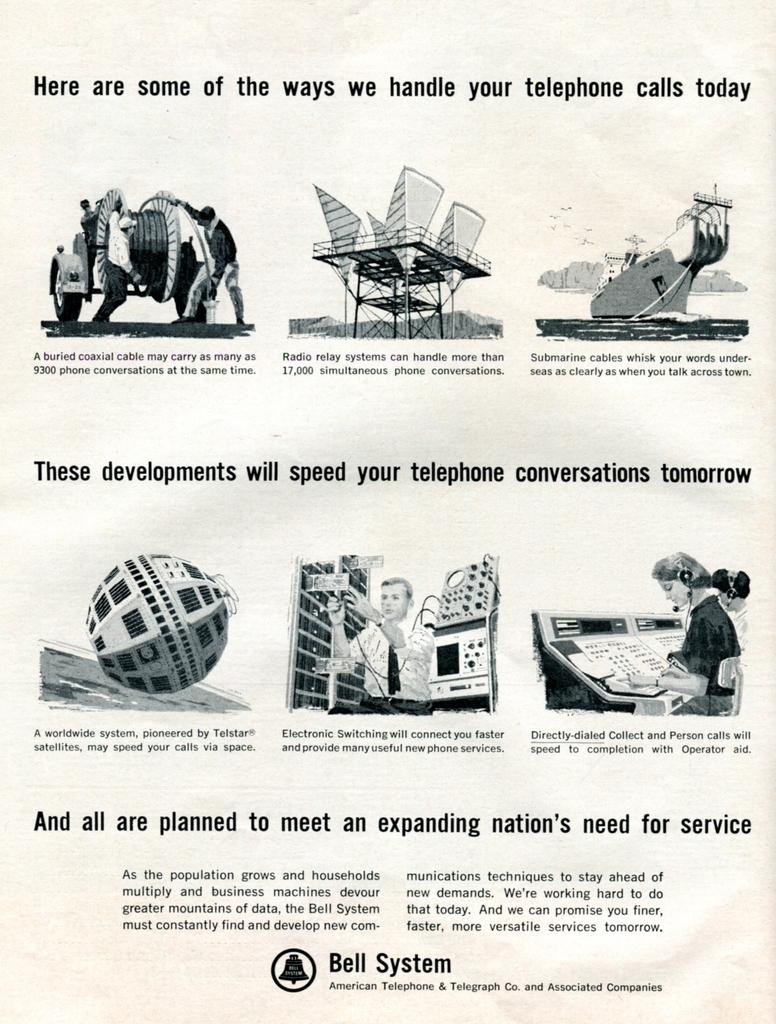What is depicted on the paper in the image? There are images of people and objects on the paper. What else can be seen on the paper? There is writing on the paper. What type of impulse can be seen affecting the people in the image? of reflective surface is present in the image? 